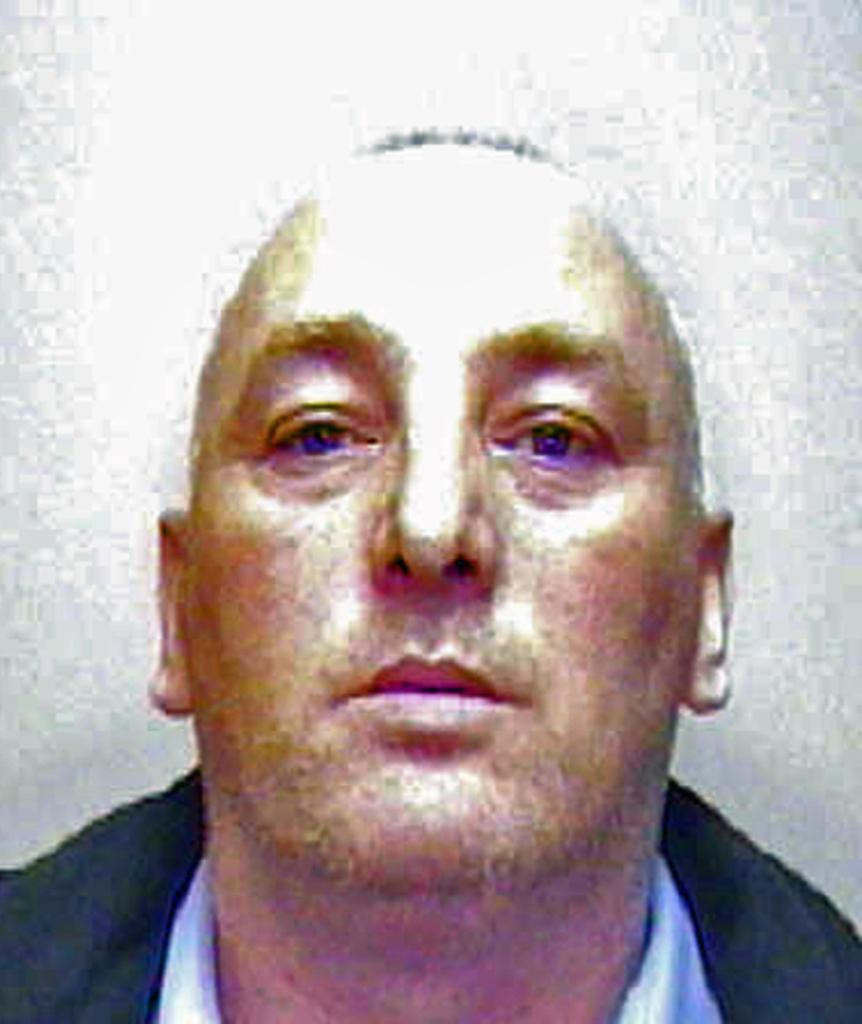What is the main subject of the image? There is a man in the image. Can you describe the background of the image? The background of the image is blurred. What type of chain is the man holding in the image? There is no chain present in the image; the man is the only subject visible. 